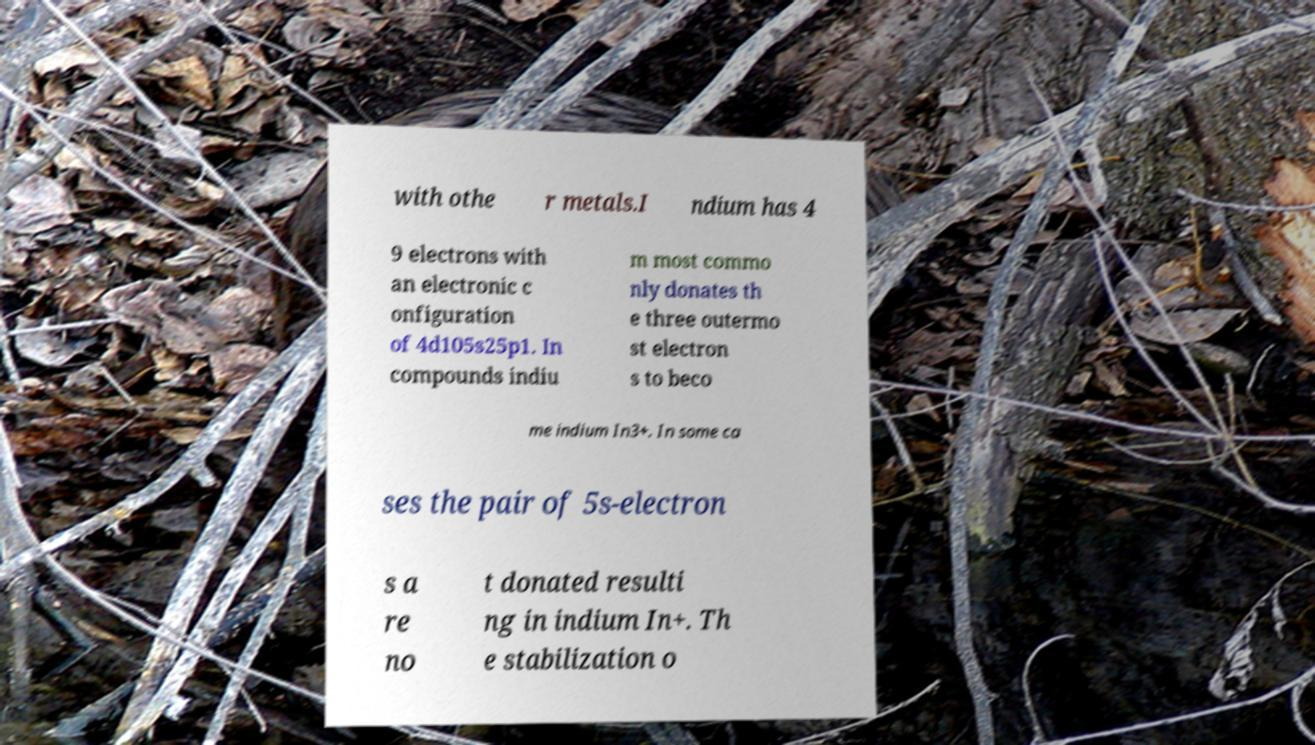Can you read and provide the text displayed in the image?This photo seems to have some interesting text. Can you extract and type it out for me? with othe r metals.I ndium has 4 9 electrons with an electronic c onfiguration of 4d105s25p1. In compounds indiu m most commo nly donates th e three outermo st electron s to beco me indium In3+. In some ca ses the pair of 5s-electron s a re no t donated resulti ng in indium In+. Th e stabilization o 